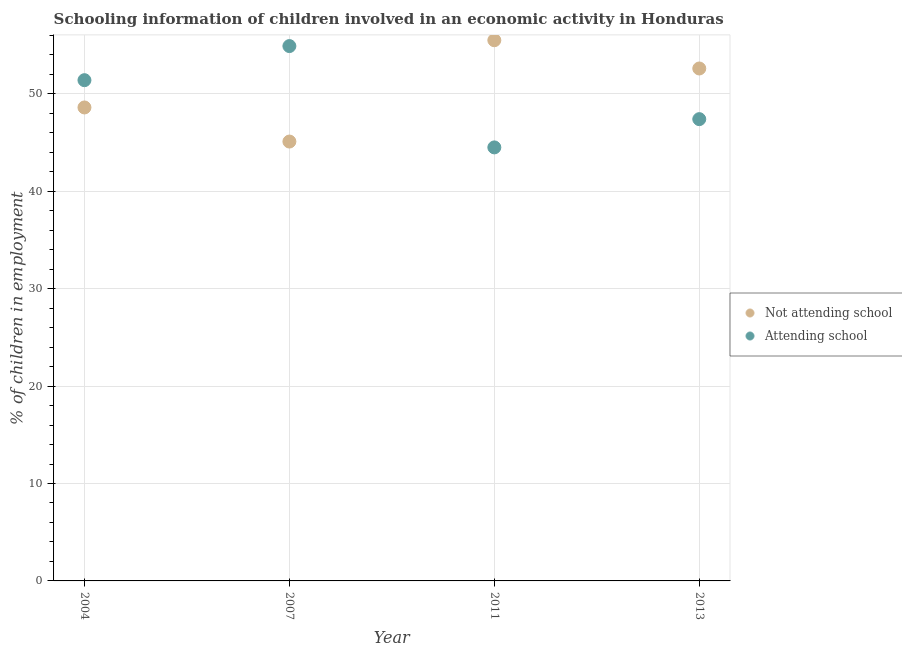How many different coloured dotlines are there?
Offer a very short reply. 2. Is the number of dotlines equal to the number of legend labels?
Ensure brevity in your answer.  Yes. What is the percentage of employed children who are attending school in 2007?
Ensure brevity in your answer.  54.9. Across all years, what is the maximum percentage of employed children who are attending school?
Give a very brief answer. 54.9. Across all years, what is the minimum percentage of employed children who are not attending school?
Keep it short and to the point. 45.1. In which year was the percentage of employed children who are attending school minimum?
Give a very brief answer. 2011. What is the total percentage of employed children who are attending school in the graph?
Give a very brief answer. 198.2. What is the difference between the percentage of employed children who are attending school in 2011 and the percentage of employed children who are not attending school in 2007?
Make the answer very short. -0.6. What is the average percentage of employed children who are not attending school per year?
Offer a terse response. 50.45. In the year 2013, what is the difference between the percentage of employed children who are not attending school and percentage of employed children who are attending school?
Make the answer very short. 5.2. What is the ratio of the percentage of employed children who are not attending school in 2011 to that in 2013?
Provide a succinct answer. 1.06. Is the percentage of employed children who are not attending school in 2004 less than that in 2013?
Make the answer very short. Yes. What is the difference between the highest and the second highest percentage of employed children who are attending school?
Provide a short and direct response. 3.5. What is the difference between the highest and the lowest percentage of employed children who are attending school?
Your answer should be compact. 10.4. In how many years, is the percentage of employed children who are not attending school greater than the average percentage of employed children who are not attending school taken over all years?
Offer a terse response. 2. Does the percentage of employed children who are not attending school monotonically increase over the years?
Provide a succinct answer. No. Is the percentage of employed children who are attending school strictly greater than the percentage of employed children who are not attending school over the years?
Your answer should be compact. No. How many dotlines are there?
Your answer should be very brief. 2. How many years are there in the graph?
Provide a succinct answer. 4. Does the graph contain any zero values?
Your answer should be very brief. No. Where does the legend appear in the graph?
Your response must be concise. Center right. How are the legend labels stacked?
Offer a very short reply. Vertical. What is the title of the graph?
Offer a very short reply. Schooling information of children involved in an economic activity in Honduras. Does "Education" appear as one of the legend labels in the graph?
Offer a terse response. No. What is the label or title of the X-axis?
Offer a very short reply. Year. What is the label or title of the Y-axis?
Your answer should be compact. % of children in employment. What is the % of children in employment in Not attending school in 2004?
Your answer should be compact. 48.6. What is the % of children in employment of Attending school in 2004?
Ensure brevity in your answer.  51.4. What is the % of children in employment in Not attending school in 2007?
Make the answer very short. 45.1. What is the % of children in employment in Attending school in 2007?
Keep it short and to the point. 54.9. What is the % of children in employment in Not attending school in 2011?
Offer a very short reply. 55.5. What is the % of children in employment in Attending school in 2011?
Your answer should be very brief. 44.5. What is the % of children in employment of Not attending school in 2013?
Make the answer very short. 52.6. What is the % of children in employment of Attending school in 2013?
Offer a very short reply. 47.4. Across all years, what is the maximum % of children in employment of Not attending school?
Make the answer very short. 55.5. Across all years, what is the maximum % of children in employment in Attending school?
Provide a succinct answer. 54.9. Across all years, what is the minimum % of children in employment in Not attending school?
Your answer should be very brief. 45.1. Across all years, what is the minimum % of children in employment of Attending school?
Ensure brevity in your answer.  44.5. What is the total % of children in employment of Not attending school in the graph?
Your answer should be compact. 201.8. What is the total % of children in employment of Attending school in the graph?
Your answer should be very brief. 198.2. What is the difference between the % of children in employment of Not attending school in 2004 and that in 2007?
Keep it short and to the point. 3.5. What is the difference between the % of children in employment of Not attending school in 2004 and that in 2011?
Make the answer very short. -6.9. What is the difference between the % of children in employment of Attending school in 2004 and that in 2013?
Provide a short and direct response. 4. What is the difference between the % of children in employment of Attending school in 2007 and that in 2013?
Give a very brief answer. 7.5. What is the difference between the % of children in employment of Not attending school in 2011 and that in 2013?
Offer a very short reply. 2.9. What is the difference between the % of children in employment of Attending school in 2011 and that in 2013?
Give a very brief answer. -2.9. What is the difference between the % of children in employment of Not attending school in 2004 and the % of children in employment of Attending school in 2011?
Offer a very short reply. 4.1. What is the difference between the % of children in employment in Not attending school in 2007 and the % of children in employment in Attending school in 2013?
Offer a very short reply. -2.3. What is the average % of children in employment in Not attending school per year?
Your response must be concise. 50.45. What is the average % of children in employment in Attending school per year?
Make the answer very short. 49.55. In the year 2011, what is the difference between the % of children in employment in Not attending school and % of children in employment in Attending school?
Offer a terse response. 11. In the year 2013, what is the difference between the % of children in employment of Not attending school and % of children in employment of Attending school?
Provide a short and direct response. 5.2. What is the ratio of the % of children in employment in Not attending school in 2004 to that in 2007?
Offer a very short reply. 1.08. What is the ratio of the % of children in employment of Attending school in 2004 to that in 2007?
Keep it short and to the point. 0.94. What is the ratio of the % of children in employment of Not attending school in 2004 to that in 2011?
Provide a succinct answer. 0.88. What is the ratio of the % of children in employment of Attending school in 2004 to that in 2011?
Offer a very short reply. 1.16. What is the ratio of the % of children in employment of Not attending school in 2004 to that in 2013?
Offer a terse response. 0.92. What is the ratio of the % of children in employment in Attending school in 2004 to that in 2013?
Provide a short and direct response. 1.08. What is the ratio of the % of children in employment of Not attending school in 2007 to that in 2011?
Offer a terse response. 0.81. What is the ratio of the % of children in employment of Attending school in 2007 to that in 2011?
Your answer should be very brief. 1.23. What is the ratio of the % of children in employment in Not attending school in 2007 to that in 2013?
Your response must be concise. 0.86. What is the ratio of the % of children in employment in Attending school in 2007 to that in 2013?
Ensure brevity in your answer.  1.16. What is the ratio of the % of children in employment in Not attending school in 2011 to that in 2013?
Give a very brief answer. 1.06. What is the ratio of the % of children in employment of Attending school in 2011 to that in 2013?
Offer a terse response. 0.94. What is the difference between the highest and the second highest % of children in employment of Not attending school?
Offer a very short reply. 2.9. What is the difference between the highest and the lowest % of children in employment in Not attending school?
Ensure brevity in your answer.  10.4. What is the difference between the highest and the lowest % of children in employment of Attending school?
Your response must be concise. 10.4. 